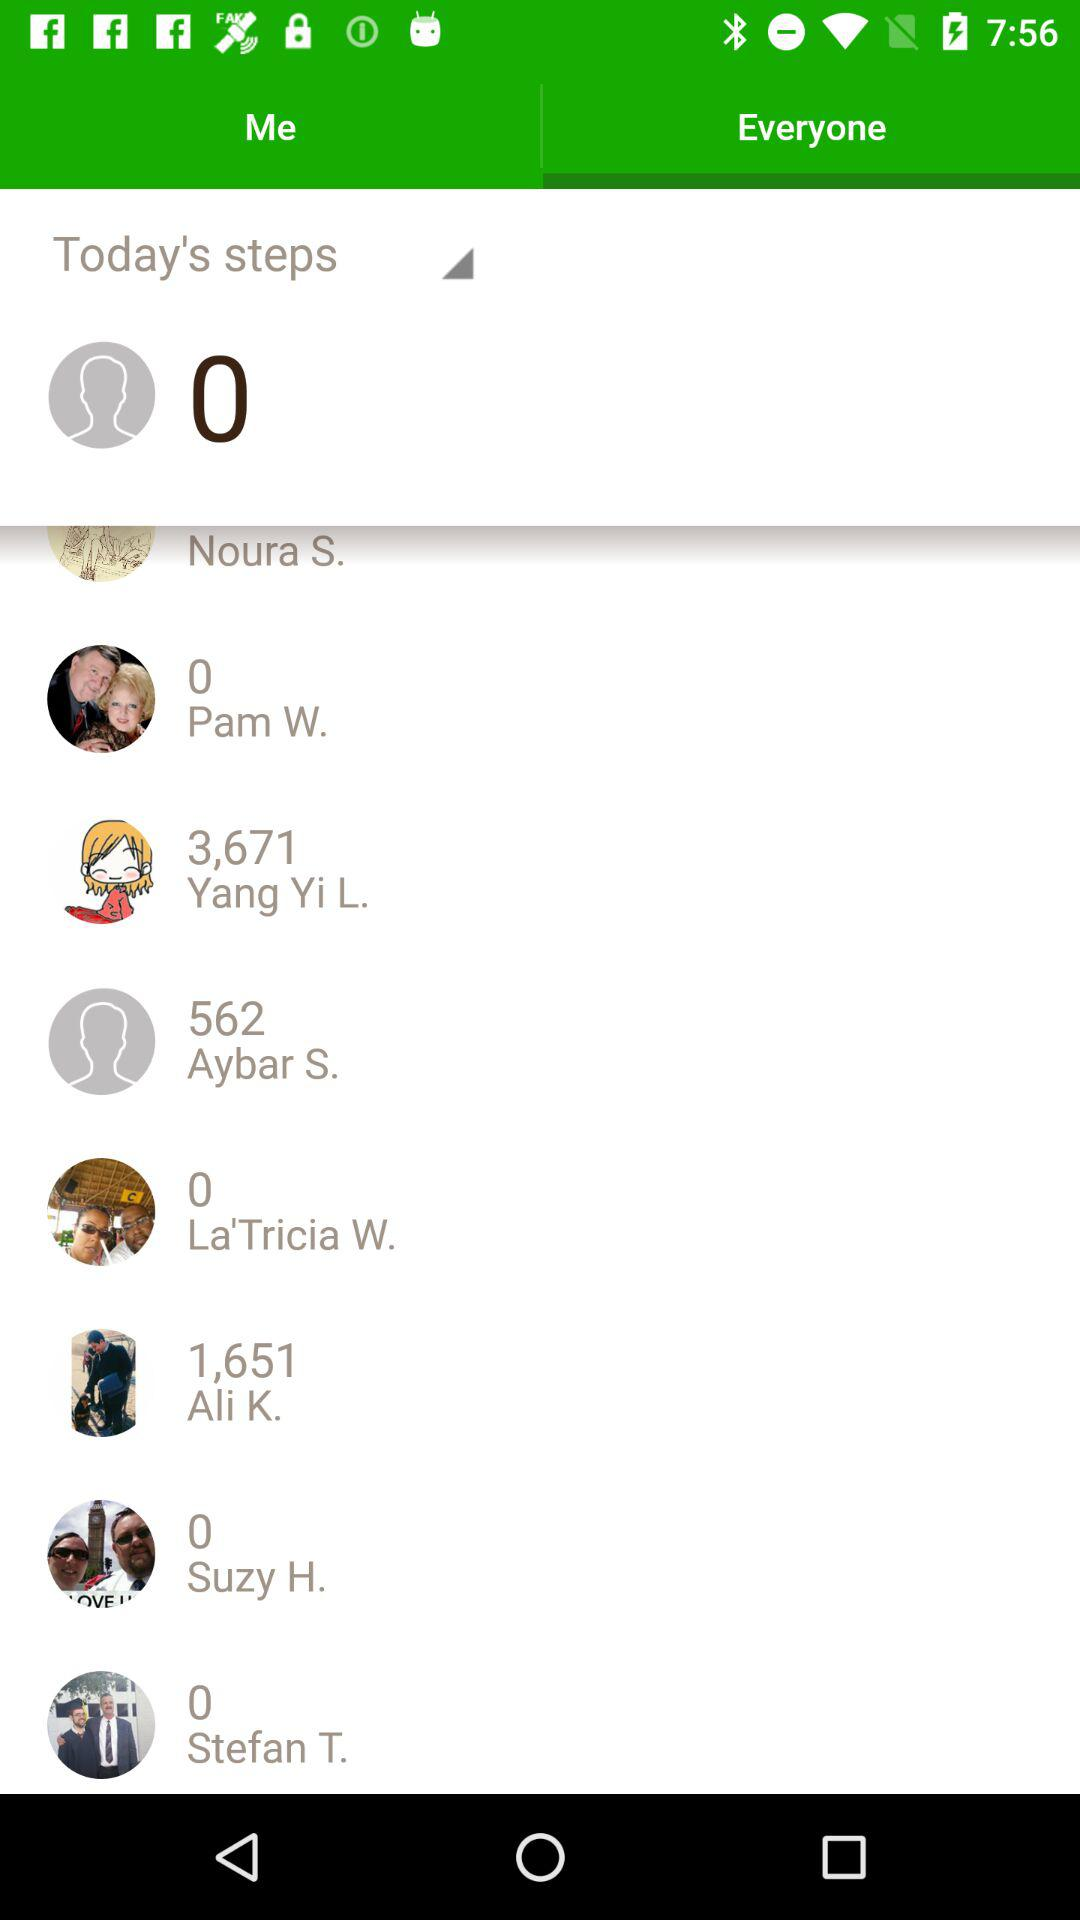How many steps did Ali K. take?
Answer the question using a single word or phrase. 1,651 